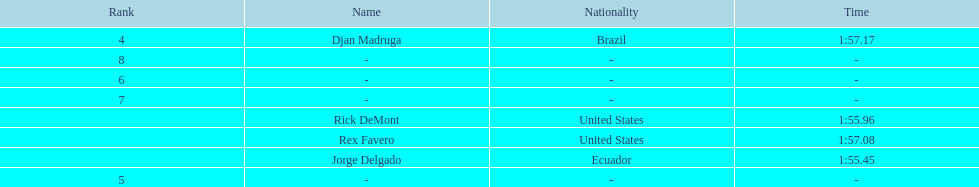What is the average time? 1:56.42. I'm looking to parse the entire table for insights. Could you assist me with that? {'header': ['Rank', 'Name', 'Nationality', 'Time'], 'rows': [['4', 'Djan Madruga', 'Brazil', '1:57.17'], ['8', '-', '-', '-'], ['6', '-', '-', '-'], ['7', '-', '-', '-'], ['', 'Rick DeMont', 'United States', '1:55.96'], ['', 'Rex Favero', 'United States', '1:57.08'], ['', 'Jorge Delgado', 'Ecuador', '1:55.45'], ['5', '-', '-', '-']]} 